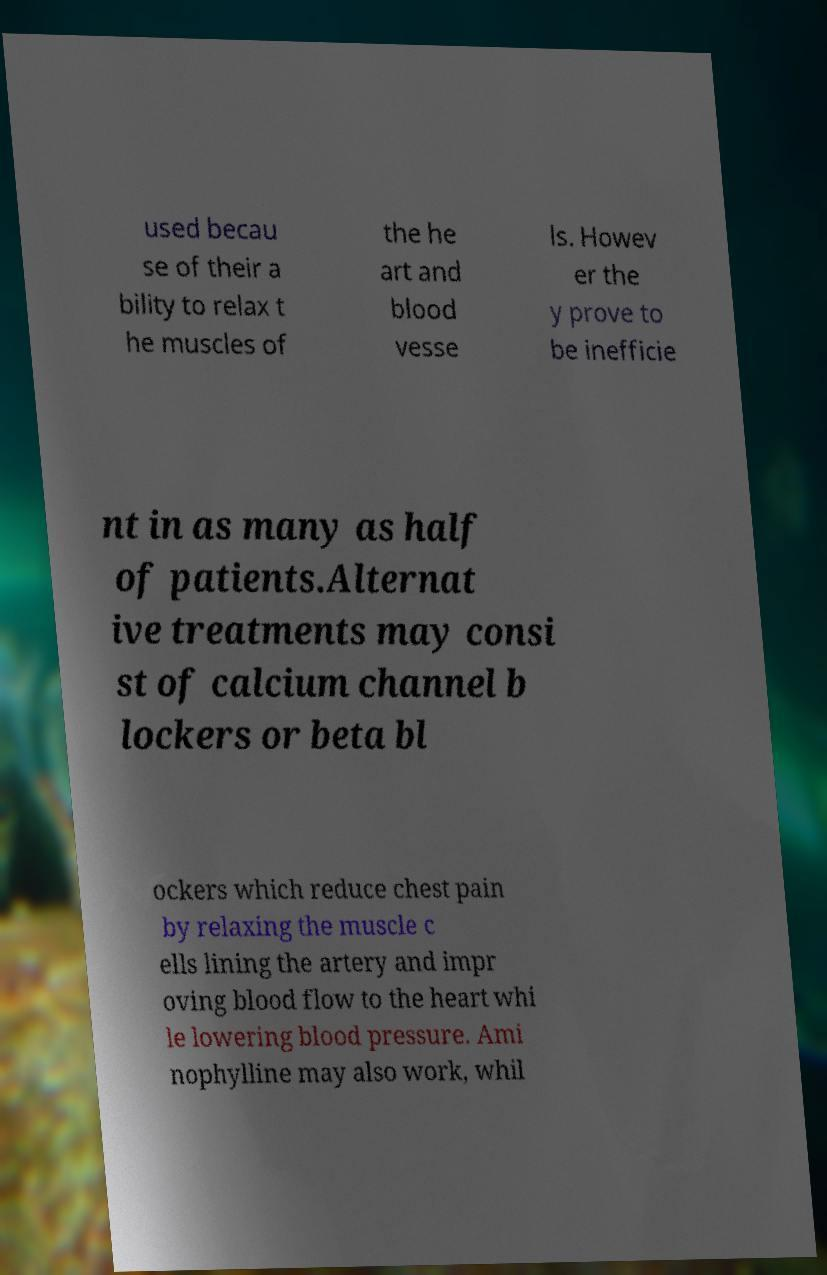Please read and relay the text visible in this image. What does it say? used becau se of their a bility to relax t he muscles of the he art and blood vesse ls. Howev er the y prove to be inefficie nt in as many as half of patients.Alternat ive treatments may consi st of calcium channel b lockers or beta bl ockers which reduce chest pain by relaxing the muscle c ells lining the artery and impr oving blood flow to the heart whi le lowering blood pressure. Ami nophylline may also work, whil 